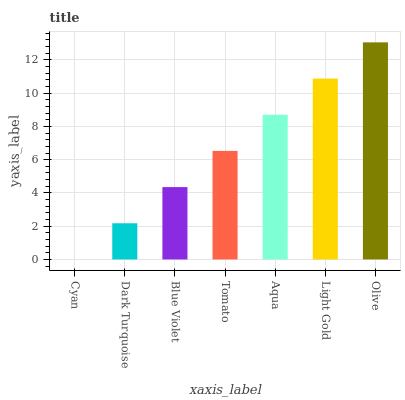Is Cyan the minimum?
Answer yes or no. Yes. Is Olive the maximum?
Answer yes or no. Yes. Is Dark Turquoise the minimum?
Answer yes or no. No. Is Dark Turquoise the maximum?
Answer yes or no. No. Is Dark Turquoise greater than Cyan?
Answer yes or no. Yes. Is Cyan less than Dark Turquoise?
Answer yes or no. Yes. Is Cyan greater than Dark Turquoise?
Answer yes or no. No. Is Dark Turquoise less than Cyan?
Answer yes or no. No. Is Tomato the high median?
Answer yes or no. Yes. Is Tomato the low median?
Answer yes or no. Yes. Is Olive the high median?
Answer yes or no. No. Is Olive the low median?
Answer yes or no. No. 